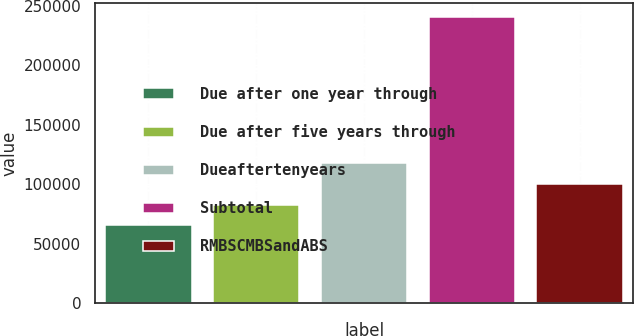Convert chart. <chart><loc_0><loc_0><loc_500><loc_500><bar_chart><fcel>Due after one year through<fcel>Due after five years through<fcel>Dueaftertenyears<fcel>Subtotal<fcel>RMBSCMBSandABS<nl><fcel>65378<fcel>82900.4<fcel>117945<fcel>240602<fcel>100423<nl></chart> 